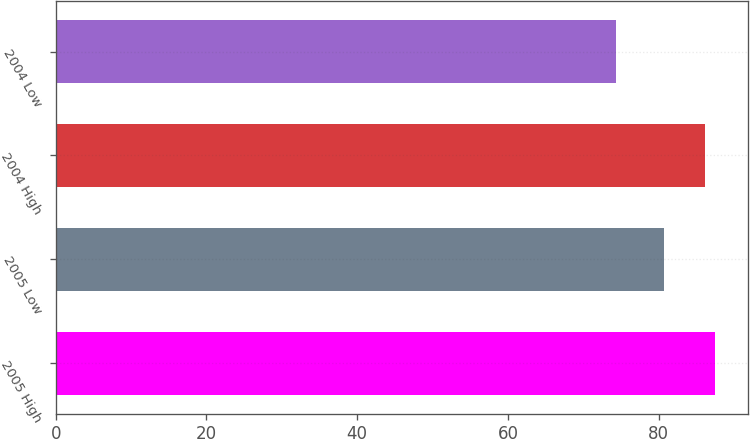Convert chart. <chart><loc_0><loc_0><loc_500><loc_500><bar_chart><fcel>2005 High<fcel>2005 Low<fcel>2004 High<fcel>2004 Low<nl><fcel>87.51<fcel>80.73<fcel>86.2<fcel>74.35<nl></chart> 